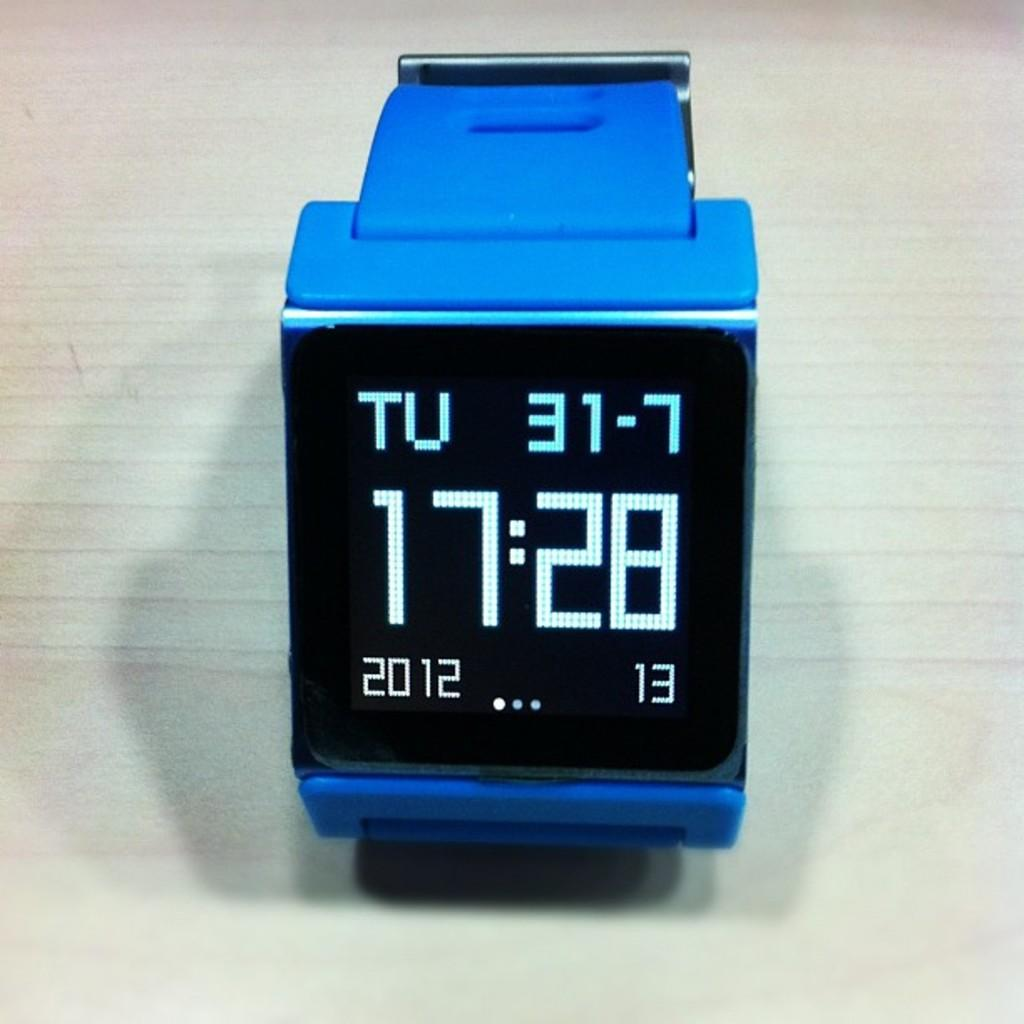<image>
Give a short and clear explanation of the subsequent image. Black and blue wristwatch that has the time at 17:28. 